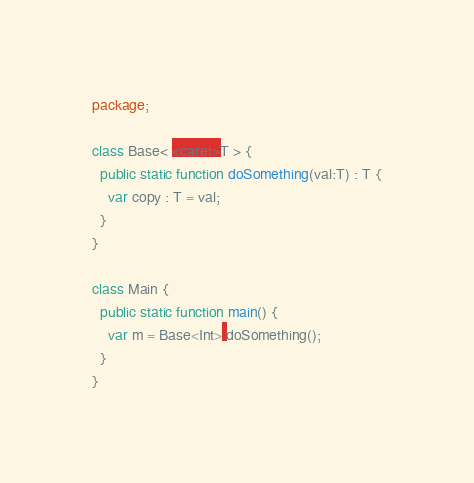Convert code to text. <code><loc_0><loc_0><loc_500><loc_500><_Haxe_>package;

class Base< <caret>T > {
  public static function doSomething(val:T) : T {
    var copy : T = val;
  }
}

class Main {
  public static function main() {
    var m = Base<Int>.doSomething();
  }
}</code> 